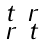Convert formula to latex. <formula><loc_0><loc_0><loc_500><loc_500>\begin{smallmatrix} t & r \\ r & t \end{smallmatrix}</formula> 